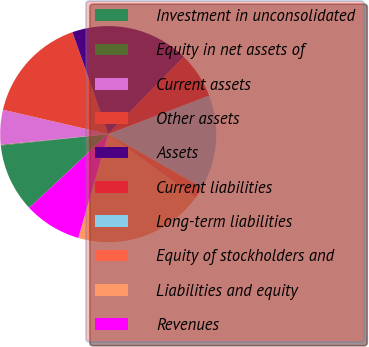Convert chart to OTSL. <chart><loc_0><loc_0><loc_500><loc_500><pie_chart><fcel>Investment in unconsolidated<fcel>Equity in net assets of<fcel>Current assets<fcel>Other assets<fcel>Assets<fcel>Current liabilities<fcel>Long-term liabilities<fcel>Equity of stockholders and<fcel>Liabilities and equity<fcel>Revenues<nl><fcel>10.27%<fcel>0.12%<fcel>5.19%<fcel>16.01%<fcel>17.7%<fcel>6.88%<fcel>14.05%<fcel>1.81%<fcel>19.39%<fcel>8.58%<nl></chart> 